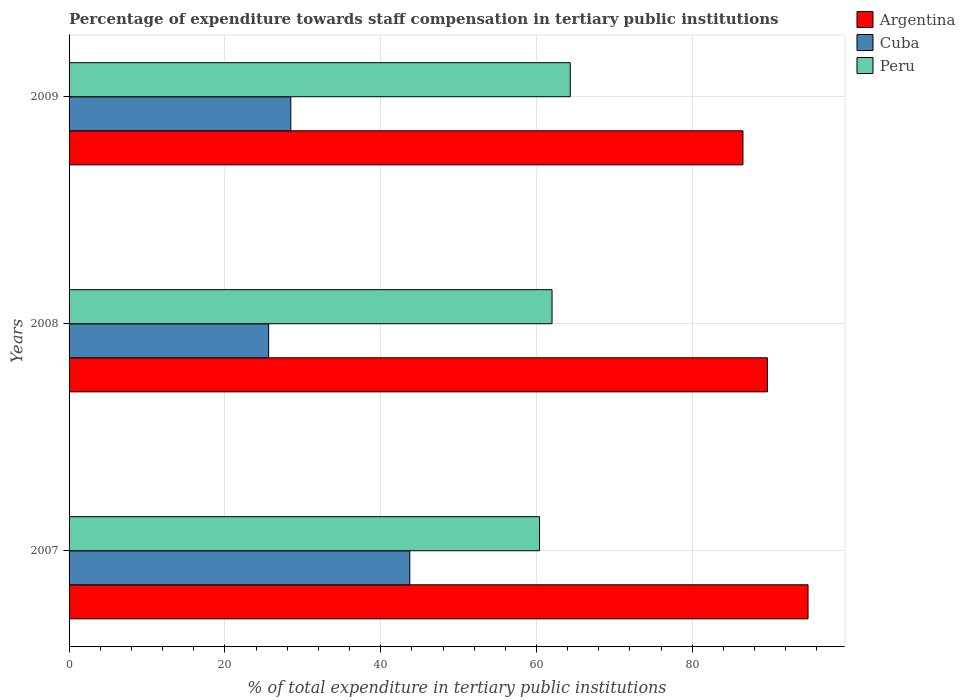Are the number of bars per tick equal to the number of legend labels?
Make the answer very short. Yes. Are the number of bars on each tick of the Y-axis equal?
Keep it short and to the point. Yes. How many bars are there on the 3rd tick from the top?
Keep it short and to the point. 3. What is the label of the 1st group of bars from the top?
Provide a succinct answer. 2009. In how many cases, is the number of bars for a given year not equal to the number of legend labels?
Your response must be concise. 0. What is the percentage of expenditure towards staff compensation in Argentina in 2008?
Your answer should be compact. 89.64. Across all years, what is the maximum percentage of expenditure towards staff compensation in Peru?
Your answer should be very brief. 64.33. Across all years, what is the minimum percentage of expenditure towards staff compensation in Cuba?
Ensure brevity in your answer.  25.62. What is the total percentage of expenditure towards staff compensation in Argentina in the graph?
Offer a terse response. 270.99. What is the difference between the percentage of expenditure towards staff compensation in Argentina in 2007 and that in 2008?
Provide a succinct answer. 5.21. What is the difference between the percentage of expenditure towards staff compensation in Cuba in 2008 and the percentage of expenditure towards staff compensation in Argentina in 2007?
Keep it short and to the point. -69.23. What is the average percentage of expenditure towards staff compensation in Cuba per year?
Your answer should be very brief. 32.61. In the year 2008, what is the difference between the percentage of expenditure towards staff compensation in Cuba and percentage of expenditure towards staff compensation in Peru?
Offer a terse response. -36.37. What is the ratio of the percentage of expenditure towards staff compensation in Cuba in 2007 to that in 2009?
Offer a terse response. 1.54. Is the percentage of expenditure towards staff compensation in Peru in 2007 less than that in 2008?
Offer a terse response. Yes. Is the difference between the percentage of expenditure towards staff compensation in Cuba in 2007 and 2009 greater than the difference between the percentage of expenditure towards staff compensation in Peru in 2007 and 2009?
Provide a short and direct response. Yes. What is the difference between the highest and the second highest percentage of expenditure towards staff compensation in Cuba?
Make the answer very short. 15.27. What is the difference between the highest and the lowest percentage of expenditure towards staff compensation in Argentina?
Your answer should be compact. 8.35. In how many years, is the percentage of expenditure towards staff compensation in Argentina greater than the average percentage of expenditure towards staff compensation in Argentina taken over all years?
Your response must be concise. 1. What does the 3rd bar from the top in 2009 represents?
Keep it short and to the point. Argentina. Are all the bars in the graph horizontal?
Make the answer very short. Yes. What is the difference between two consecutive major ticks on the X-axis?
Ensure brevity in your answer.  20. Are the values on the major ticks of X-axis written in scientific E-notation?
Make the answer very short. No. Does the graph contain grids?
Your answer should be compact. Yes. How many legend labels are there?
Provide a short and direct response. 3. How are the legend labels stacked?
Offer a very short reply. Vertical. What is the title of the graph?
Offer a terse response. Percentage of expenditure towards staff compensation in tertiary public institutions. What is the label or title of the X-axis?
Offer a very short reply. % of total expenditure in tertiary public institutions. What is the label or title of the Y-axis?
Provide a short and direct response. Years. What is the % of total expenditure in tertiary public institutions of Argentina in 2007?
Your answer should be compact. 94.85. What is the % of total expenditure in tertiary public institutions of Cuba in 2007?
Your answer should be compact. 43.74. What is the % of total expenditure in tertiary public institutions in Peru in 2007?
Keep it short and to the point. 60.39. What is the % of total expenditure in tertiary public institutions in Argentina in 2008?
Offer a terse response. 89.64. What is the % of total expenditure in tertiary public institutions in Cuba in 2008?
Offer a very short reply. 25.62. What is the % of total expenditure in tertiary public institutions in Peru in 2008?
Give a very brief answer. 61.99. What is the % of total expenditure in tertiary public institutions in Argentina in 2009?
Ensure brevity in your answer.  86.5. What is the % of total expenditure in tertiary public institutions in Cuba in 2009?
Your response must be concise. 28.46. What is the % of total expenditure in tertiary public institutions of Peru in 2009?
Ensure brevity in your answer.  64.33. Across all years, what is the maximum % of total expenditure in tertiary public institutions of Argentina?
Provide a short and direct response. 94.85. Across all years, what is the maximum % of total expenditure in tertiary public institutions in Cuba?
Offer a terse response. 43.74. Across all years, what is the maximum % of total expenditure in tertiary public institutions of Peru?
Ensure brevity in your answer.  64.33. Across all years, what is the minimum % of total expenditure in tertiary public institutions of Argentina?
Your answer should be compact. 86.5. Across all years, what is the minimum % of total expenditure in tertiary public institutions in Cuba?
Give a very brief answer. 25.62. Across all years, what is the minimum % of total expenditure in tertiary public institutions in Peru?
Provide a succinct answer. 60.39. What is the total % of total expenditure in tertiary public institutions in Argentina in the graph?
Offer a terse response. 270.99. What is the total % of total expenditure in tertiary public institutions in Cuba in the graph?
Give a very brief answer. 97.82. What is the total % of total expenditure in tertiary public institutions of Peru in the graph?
Give a very brief answer. 186.71. What is the difference between the % of total expenditure in tertiary public institutions in Argentina in 2007 and that in 2008?
Provide a succinct answer. 5.21. What is the difference between the % of total expenditure in tertiary public institutions in Cuba in 2007 and that in 2008?
Your response must be concise. 18.12. What is the difference between the % of total expenditure in tertiary public institutions of Peru in 2007 and that in 2008?
Provide a succinct answer. -1.61. What is the difference between the % of total expenditure in tertiary public institutions in Argentina in 2007 and that in 2009?
Ensure brevity in your answer.  8.35. What is the difference between the % of total expenditure in tertiary public institutions of Cuba in 2007 and that in 2009?
Your response must be concise. 15.27. What is the difference between the % of total expenditure in tertiary public institutions in Peru in 2007 and that in 2009?
Provide a short and direct response. -3.94. What is the difference between the % of total expenditure in tertiary public institutions of Argentina in 2008 and that in 2009?
Give a very brief answer. 3.14. What is the difference between the % of total expenditure in tertiary public institutions in Cuba in 2008 and that in 2009?
Your answer should be very brief. -2.84. What is the difference between the % of total expenditure in tertiary public institutions of Peru in 2008 and that in 2009?
Make the answer very short. -2.34. What is the difference between the % of total expenditure in tertiary public institutions of Argentina in 2007 and the % of total expenditure in tertiary public institutions of Cuba in 2008?
Offer a terse response. 69.23. What is the difference between the % of total expenditure in tertiary public institutions in Argentina in 2007 and the % of total expenditure in tertiary public institutions in Peru in 2008?
Offer a very short reply. 32.86. What is the difference between the % of total expenditure in tertiary public institutions of Cuba in 2007 and the % of total expenditure in tertiary public institutions of Peru in 2008?
Your response must be concise. -18.26. What is the difference between the % of total expenditure in tertiary public institutions in Argentina in 2007 and the % of total expenditure in tertiary public institutions in Cuba in 2009?
Your answer should be compact. 66.39. What is the difference between the % of total expenditure in tertiary public institutions in Argentina in 2007 and the % of total expenditure in tertiary public institutions in Peru in 2009?
Provide a succinct answer. 30.52. What is the difference between the % of total expenditure in tertiary public institutions of Cuba in 2007 and the % of total expenditure in tertiary public institutions of Peru in 2009?
Offer a very short reply. -20.59. What is the difference between the % of total expenditure in tertiary public institutions of Argentina in 2008 and the % of total expenditure in tertiary public institutions of Cuba in 2009?
Provide a short and direct response. 61.18. What is the difference between the % of total expenditure in tertiary public institutions of Argentina in 2008 and the % of total expenditure in tertiary public institutions of Peru in 2009?
Give a very brief answer. 25.31. What is the difference between the % of total expenditure in tertiary public institutions in Cuba in 2008 and the % of total expenditure in tertiary public institutions in Peru in 2009?
Keep it short and to the point. -38.71. What is the average % of total expenditure in tertiary public institutions in Argentina per year?
Your answer should be compact. 90.33. What is the average % of total expenditure in tertiary public institutions of Cuba per year?
Offer a very short reply. 32.61. What is the average % of total expenditure in tertiary public institutions of Peru per year?
Offer a terse response. 62.24. In the year 2007, what is the difference between the % of total expenditure in tertiary public institutions in Argentina and % of total expenditure in tertiary public institutions in Cuba?
Provide a short and direct response. 51.12. In the year 2007, what is the difference between the % of total expenditure in tertiary public institutions of Argentina and % of total expenditure in tertiary public institutions of Peru?
Provide a succinct answer. 34.46. In the year 2007, what is the difference between the % of total expenditure in tertiary public institutions of Cuba and % of total expenditure in tertiary public institutions of Peru?
Keep it short and to the point. -16.65. In the year 2008, what is the difference between the % of total expenditure in tertiary public institutions in Argentina and % of total expenditure in tertiary public institutions in Cuba?
Offer a terse response. 64.02. In the year 2008, what is the difference between the % of total expenditure in tertiary public institutions in Argentina and % of total expenditure in tertiary public institutions in Peru?
Offer a very short reply. 27.65. In the year 2008, what is the difference between the % of total expenditure in tertiary public institutions of Cuba and % of total expenditure in tertiary public institutions of Peru?
Provide a succinct answer. -36.37. In the year 2009, what is the difference between the % of total expenditure in tertiary public institutions in Argentina and % of total expenditure in tertiary public institutions in Cuba?
Provide a succinct answer. 58.04. In the year 2009, what is the difference between the % of total expenditure in tertiary public institutions in Argentina and % of total expenditure in tertiary public institutions in Peru?
Your answer should be compact. 22.17. In the year 2009, what is the difference between the % of total expenditure in tertiary public institutions of Cuba and % of total expenditure in tertiary public institutions of Peru?
Ensure brevity in your answer.  -35.87. What is the ratio of the % of total expenditure in tertiary public institutions in Argentina in 2007 to that in 2008?
Your answer should be very brief. 1.06. What is the ratio of the % of total expenditure in tertiary public institutions in Cuba in 2007 to that in 2008?
Your response must be concise. 1.71. What is the ratio of the % of total expenditure in tertiary public institutions of Peru in 2007 to that in 2008?
Your response must be concise. 0.97. What is the ratio of the % of total expenditure in tertiary public institutions in Argentina in 2007 to that in 2009?
Make the answer very short. 1.1. What is the ratio of the % of total expenditure in tertiary public institutions of Cuba in 2007 to that in 2009?
Provide a short and direct response. 1.54. What is the ratio of the % of total expenditure in tertiary public institutions of Peru in 2007 to that in 2009?
Ensure brevity in your answer.  0.94. What is the ratio of the % of total expenditure in tertiary public institutions in Argentina in 2008 to that in 2009?
Provide a succinct answer. 1.04. What is the ratio of the % of total expenditure in tertiary public institutions in Cuba in 2008 to that in 2009?
Your answer should be very brief. 0.9. What is the ratio of the % of total expenditure in tertiary public institutions in Peru in 2008 to that in 2009?
Provide a succinct answer. 0.96. What is the difference between the highest and the second highest % of total expenditure in tertiary public institutions of Argentina?
Offer a very short reply. 5.21. What is the difference between the highest and the second highest % of total expenditure in tertiary public institutions in Cuba?
Keep it short and to the point. 15.27. What is the difference between the highest and the second highest % of total expenditure in tertiary public institutions in Peru?
Make the answer very short. 2.34. What is the difference between the highest and the lowest % of total expenditure in tertiary public institutions in Argentina?
Offer a terse response. 8.35. What is the difference between the highest and the lowest % of total expenditure in tertiary public institutions in Cuba?
Keep it short and to the point. 18.12. What is the difference between the highest and the lowest % of total expenditure in tertiary public institutions of Peru?
Ensure brevity in your answer.  3.94. 